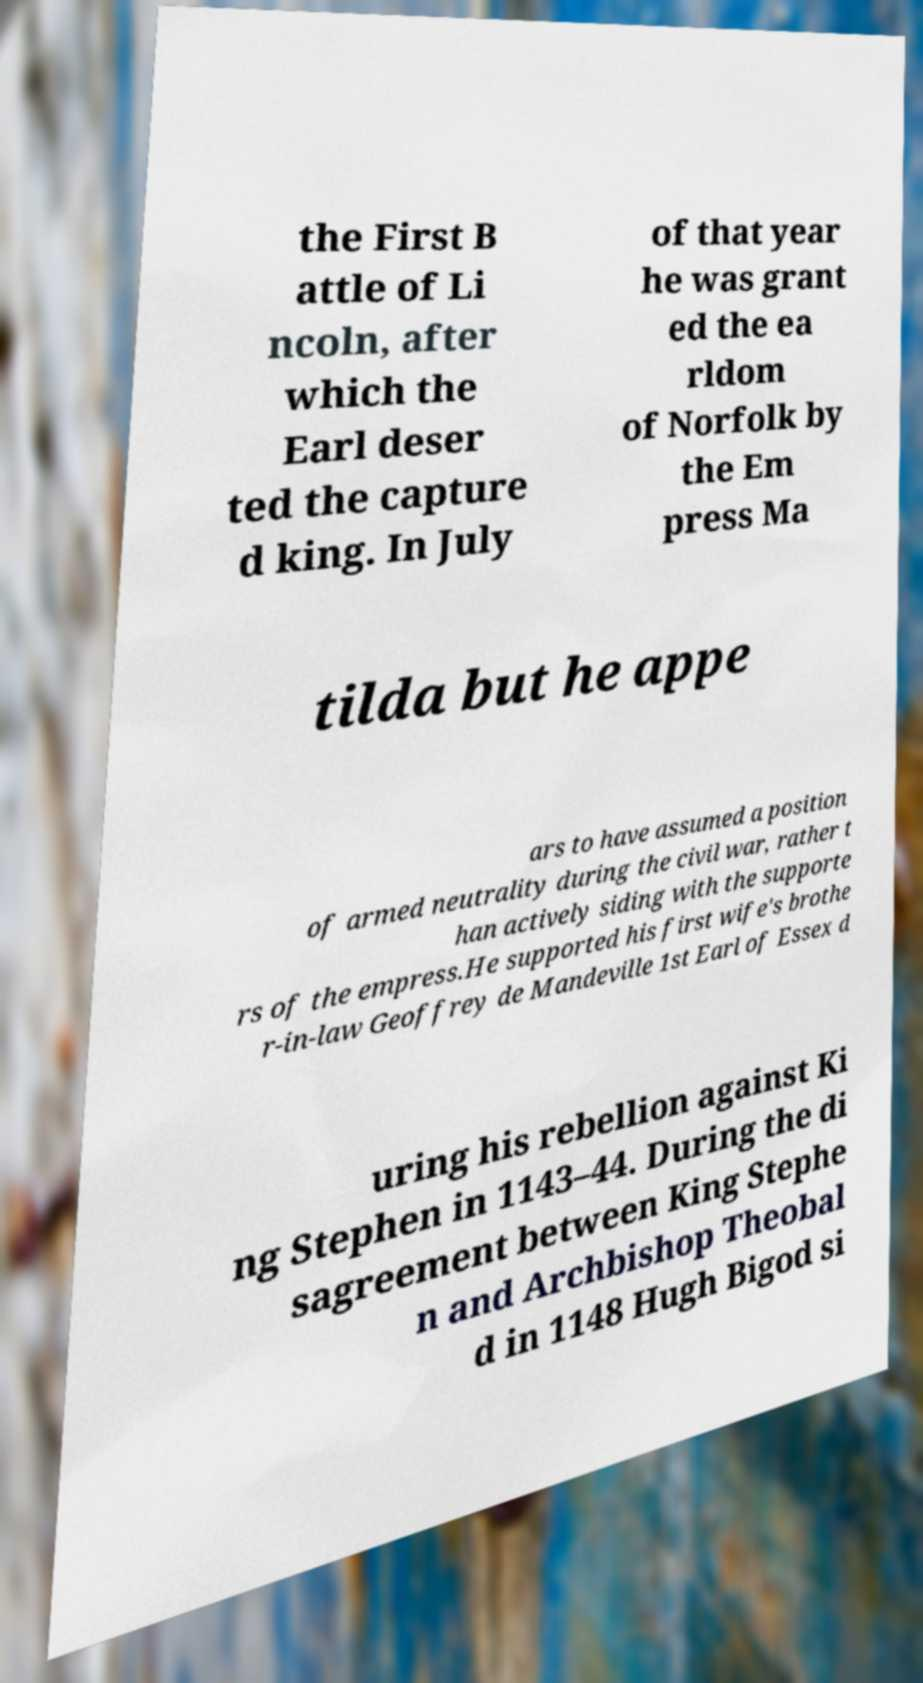Can you accurately transcribe the text from the provided image for me? the First B attle of Li ncoln, after which the Earl deser ted the capture d king. In July of that year he was grant ed the ea rldom of Norfolk by the Em press Ma tilda but he appe ars to have assumed a position of armed neutrality during the civil war, rather t han actively siding with the supporte rs of the empress.He supported his first wife's brothe r-in-law Geoffrey de Mandeville 1st Earl of Essex d uring his rebellion against Ki ng Stephen in 1143–44. During the di sagreement between King Stephe n and Archbishop Theobal d in 1148 Hugh Bigod si 